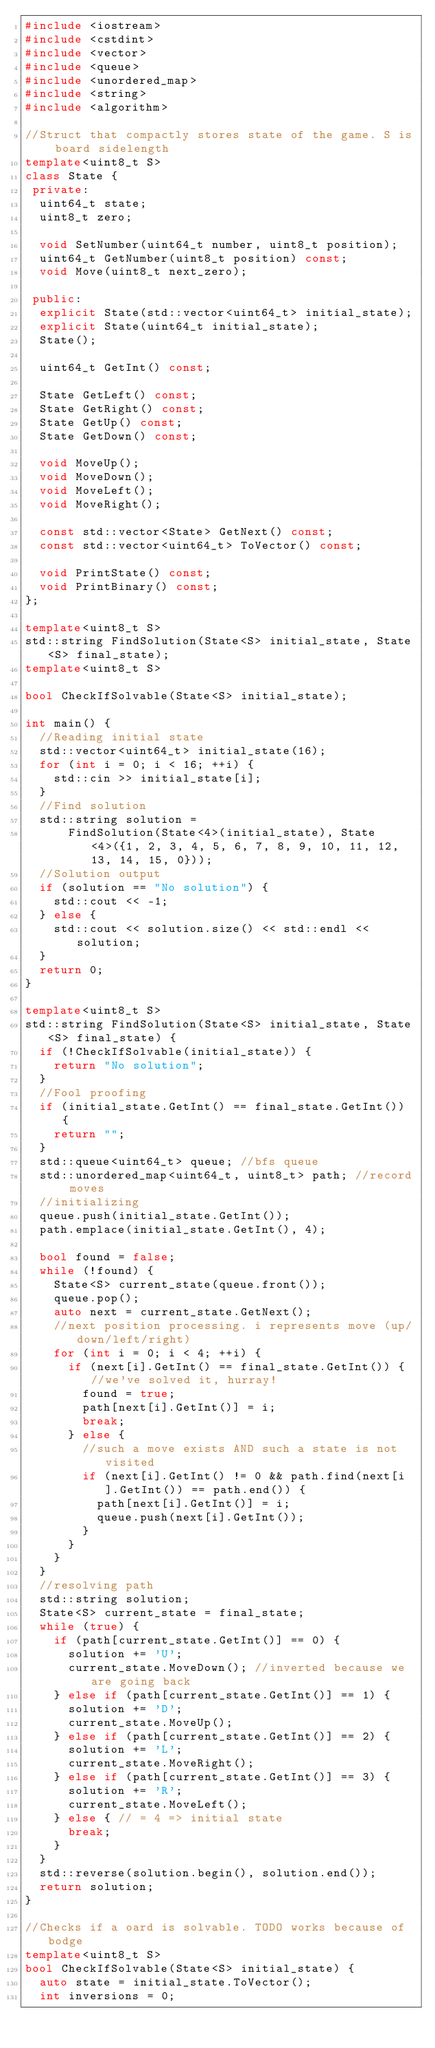Convert code to text. <code><loc_0><loc_0><loc_500><loc_500><_C++_>#include <iostream>
#include <cstdint>
#include <vector>
#include <queue>
#include <unordered_map>
#include <string>
#include <algorithm>

//Struct that compactly stores state of the game. S is board sidelength
template<uint8_t S>
class State {
 private:
  uint64_t state;
  uint8_t zero;

  void SetNumber(uint64_t number, uint8_t position);
  uint64_t GetNumber(uint8_t position) const;
  void Move(uint8_t next_zero);

 public:
  explicit State(std::vector<uint64_t> initial_state);
  explicit State(uint64_t initial_state);
  State();

  uint64_t GetInt() const;

  State GetLeft() const;
  State GetRight() const;
  State GetUp() const;
  State GetDown() const;

  void MoveUp();
  void MoveDown();
  void MoveLeft();
  void MoveRight();

  const std::vector<State> GetNext() const;
  const std::vector<uint64_t> ToVector() const;

  void PrintState() const;
  void PrintBinary() const;
};

template<uint8_t S>
std::string FindSolution(State<S> initial_state, State<S> final_state);
template<uint8_t S>

bool CheckIfSolvable(State<S> initial_state);

int main() {
  //Reading initial state
  std::vector<uint64_t> initial_state(16);
  for (int i = 0; i < 16; ++i) {
    std::cin >> initial_state[i];
  }
  //Find solution
  std::string solution =
      FindSolution(State<4>(initial_state), State<4>({1, 2, 3, 4, 5, 6, 7, 8, 9, 10, 11, 12, 13, 14, 15, 0}));
  //Solution output
  if (solution == "No solution") {
    std::cout << -1;
  } else {
    std::cout << solution.size() << std::endl << solution;
  }
  return 0;
}

template<uint8_t S>
std::string FindSolution(State<S> initial_state, State<S> final_state) {
  if (!CheckIfSolvable(initial_state)) {
    return "No solution";
  }
  //Fool proofing
  if (initial_state.GetInt() == final_state.GetInt()) {
    return "";
  }
  std::queue<uint64_t> queue; //bfs queue
  std::unordered_map<uint64_t, uint8_t> path; //record moves
  //initializing
  queue.push(initial_state.GetInt());
  path.emplace(initial_state.GetInt(), 4);

  bool found = false;
  while (!found) {
    State<S> current_state(queue.front());
    queue.pop();
    auto next = current_state.GetNext();
    //next position processing. i represents move (up/down/left/right)
    for (int i = 0; i < 4; ++i) {
      if (next[i].GetInt() == final_state.GetInt()) { //we've solved it, hurray!
        found = true;
        path[next[i].GetInt()] = i;
        break;
      } else {
        //such a move exists AND such a state is not visited
        if (next[i].GetInt() != 0 && path.find(next[i].GetInt()) == path.end()) {
          path[next[i].GetInt()] = i;
          queue.push(next[i].GetInt());
        }
      }
    }
  }
  //resolving path
  std::string solution;
  State<S> current_state = final_state;
  while (true) {
    if (path[current_state.GetInt()] == 0) {
      solution += 'U';
      current_state.MoveDown(); //inverted because we are going back
    } else if (path[current_state.GetInt()] == 1) {
      solution += 'D';
      current_state.MoveUp();
    } else if (path[current_state.GetInt()] == 2) {
      solution += 'L';
      current_state.MoveRight();
    } else if (path[current_state.GetInt()] == 3) {
      solution += 'R';
      current_state.MoveLeft();
    } else { // = 4 => initial state
      break;
    }
  }
  std::reverse(solution.begin(), solution.end());
  return solution;
}

//Checks if a oard is solvable. TODO works because of bodge
template<uint8_t S>
bool CheckIfSolvable(State<S> initial_state) {
  auto state = initial_state.ToVector();
  int inversions = 0;</code> 